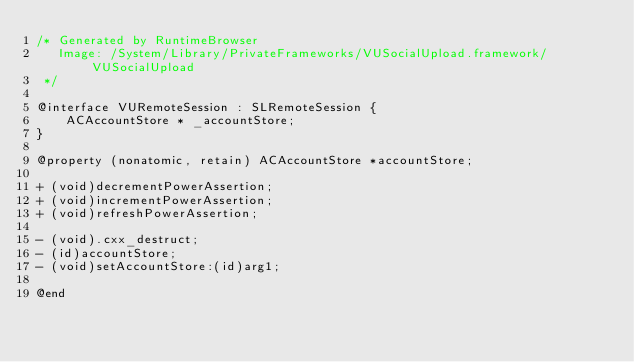<code> <loc_0><loc_0><loc_500><loc_500><_C_>/* Generated by RuntimeBrowser
   Image: /System/Library/PrivateFrameworks/VUSocialUpload.framework/VUSocialUpload
 */

@interface VURemoteSession : SLRemoteSession {
    ACAccountStore * _accountStore;
}

@property (nonatomic, retain) ACAccountStore *accountStore;

+ (void)decrementPowerAssertion;
+ (void)incrementPowerAssertion;
+ (void)refreshPowerAssertion;

- (void).cxx_destruct;
- (id)accountStore;
- (void)setAccountStore:(id)arg1;

@end
</code> 